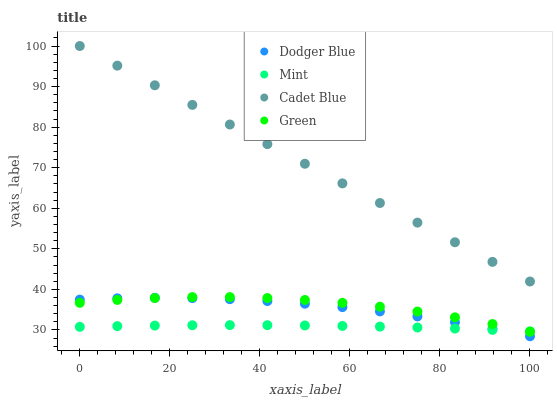Does Mint have the minimum area under the curve?
Answer yes or no. Yes. Does Cadet Blue have the maximum area under the curve?
Answer yes or no. Yes. Does Dodger Blue have the minimum area under the curve?
Answer yes or no. No. Does Dodger Blue have the maximum area under the curve?
Answer yes or no. No. Is Cadet Blue the smoothest?
Answer yes or no. Yes. Is Green the roughest?
Answer yes or no. Yes. Is Dodger Blue the smoothest?
Answer yes or no. No. Is Dodger Blue the roughest?
Answer yes or no. No. Does Dodger Blue have the lowest value?
Answer yes or no. Yes. Does Cadet Blue have the lowest value?
Answer yes or no. No. Does Cadet Blue have the highest value?
Answer yes or no. Yes. Does Dodger Blue have the highest value?
Answer yes or no. No. Is Dodger Blue less than Cadet Blue?
Answer yes or no. Yes. Is Cadet Blue greater than Dodger Blue?
Answer yes or no. Yes. Does Mint intersect Green?
Answer yes or no. Yes. Is Mint less than Green?
Answer yes or no. No. Is Mint greater than Green?
Answer yes or no. No. Does Dodger Blue intersect Cadet Blue?
Answer yes or no. No. 